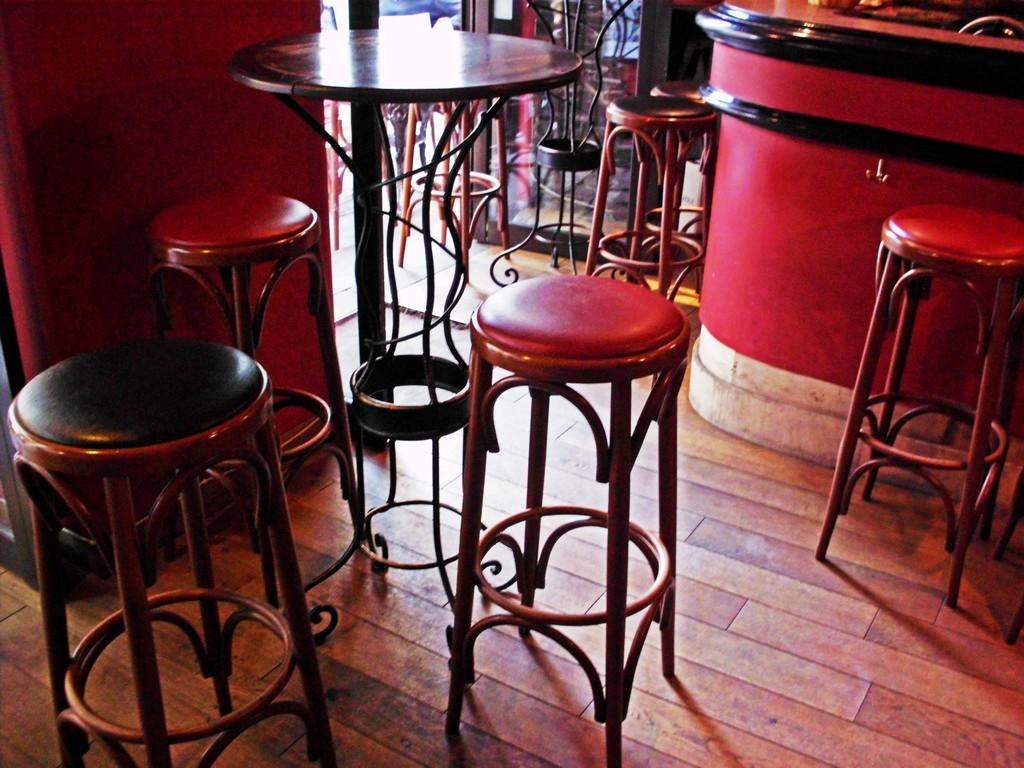What type of furniture is present in the image? There are stools in the image. What other piece of furniture can be seen in the image? There is a table in the image. Is there any other surface visible in the image? Yes, there is a counter in the image. What type of record is being played on the counter in the image? There is no record or music player present in the image; it only features stools, a table, and a counter. 